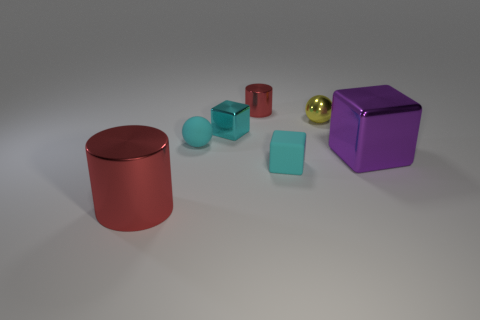Are there the same number of large shiny things to the right of the cyan ball and tiny gray metal cylinders?
Keep it short and to the point. No. The tiny metallic object that is the same color as the big metallic cylinder is what shape?
Make the answer very short. Cylinder. What number of other shiny spheres are the same size as the yellow sphere?
Offer a terse response. 0. What number of metal objects are to the left of the large purple shiny block?
Offer a very short reply. 4. What is the material of the small ball that is left of the small block to the left of the tiny cylinder?
Keep it short and to the point. Rubber. Are there any shiny cylinders of the same color as the small rubber sphere?
Offer a terse response. No. What is the size of the yellow sphere that is the same material as the big cylinder?
Give a very brief answer. Small. Is there anything else of the same color as the shiny sphere?
Make the answer very short. No. There is a big object that is behind the large red cylinder; what color is it?
Give a very brief answer. Purple. There is a small shiny thing that is behind the tiny ball that is behind the matte sphere; is there a metal cylinder that is on the left side of it?
Provide a succinct answer. Yes. 